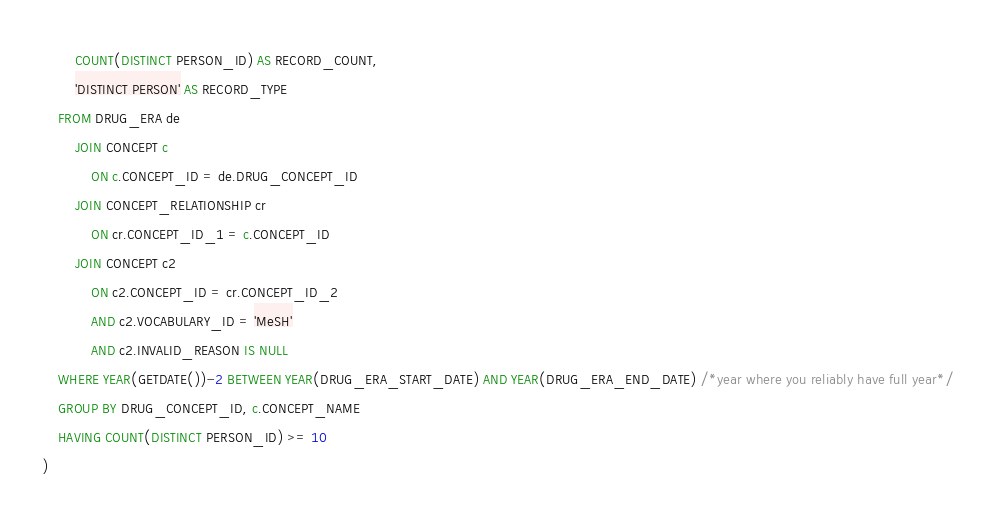<code> <loc_0><loc_0><loc_500><loc_500><_SQL_>		COUNT(DISTINCT PERSON_ID) AS RECORD_COUNT,
		'DISTINCT PERSON' AS RECORD_TYPE
	FROM DRUG_ERA de
		JOIN CONCEPT c
			ON c.CONCEPT_ID = de.DRUG_CONCEPT_ID
		JOIN CONCEPT_RELATIONSHIP cr
			ON cr.CONCEPT_ID_1 = c.CONCEPT_ID
		JOIN CONCEPT c2
			ON c2.CONCEPT_ID = cr.CONCEPT_ID_2
			AND c2.VOCABULARY_ID = 'MeSH'
			AND c2.INVALID_REASON IS NULL
	WHERE YEAR(GETDATE())-2 BETWEEN YEAR(DRUG_ERA_START_DATE) AND YEAR(DRUG_ERA_END_DATE) /*year where you reliably have full year*/
	GROUP BY DRUG_CONCEPT_ID, c.CONCEPT_NAME
	HAVING COUNT(DISTINCT PERSON_ID) >= 10
)</code> 